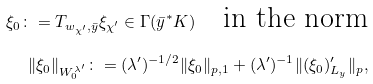<formula> <loc_0><loc_0><loc_500><loc_500>\xi _ { 0 } \colon = T _ { w _ { \chi ^ { \prime } } , \bar { y } } \xi _ { \chi ^ { \prime } } \in \Gamma ( \bar { y } ^ { * } K ) \quad \text {in the norm} \\ \| \xi _ { 0 } \| _ { W _ { 0 } ^ { \lambda ^ { \prime } } } \colon = ( \lambda ^ { \prime } ) ^ { - 1 / 2 } \| \xi _ { 0 } \| _ { p , 1 } + ( \lambda ^ { \prime } ) ^ { - 1 } \| ( \xi _ { 0 } ) ^ { \prime } _ { L _ { y } } \| _ { p } ,</formula> 